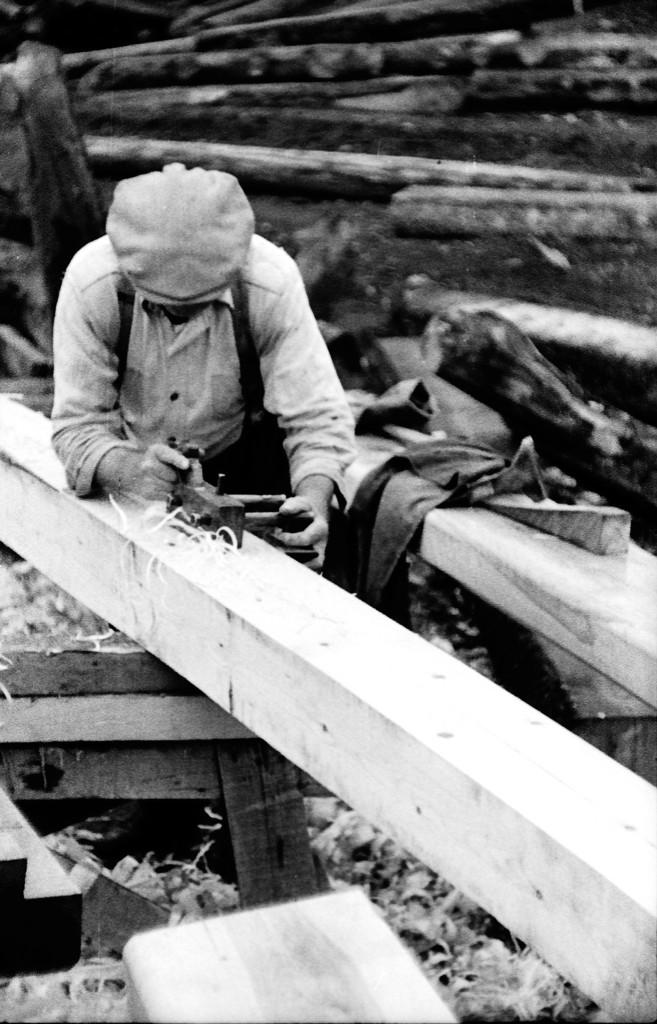What is the man in the image doing? The man is standing in the image. What is the man holding in the image? The man is holding a tool. What is in front of the man in the image? There is a wooden plank in front of the man. What can be seen in the background of the image? There are trunks of trees in the background of the image. What arithmetic problem is the man solving in the image? There is no arithmetic problem visible in the image. What time is displayed on the clock in the image? There is no clock present in the image. 